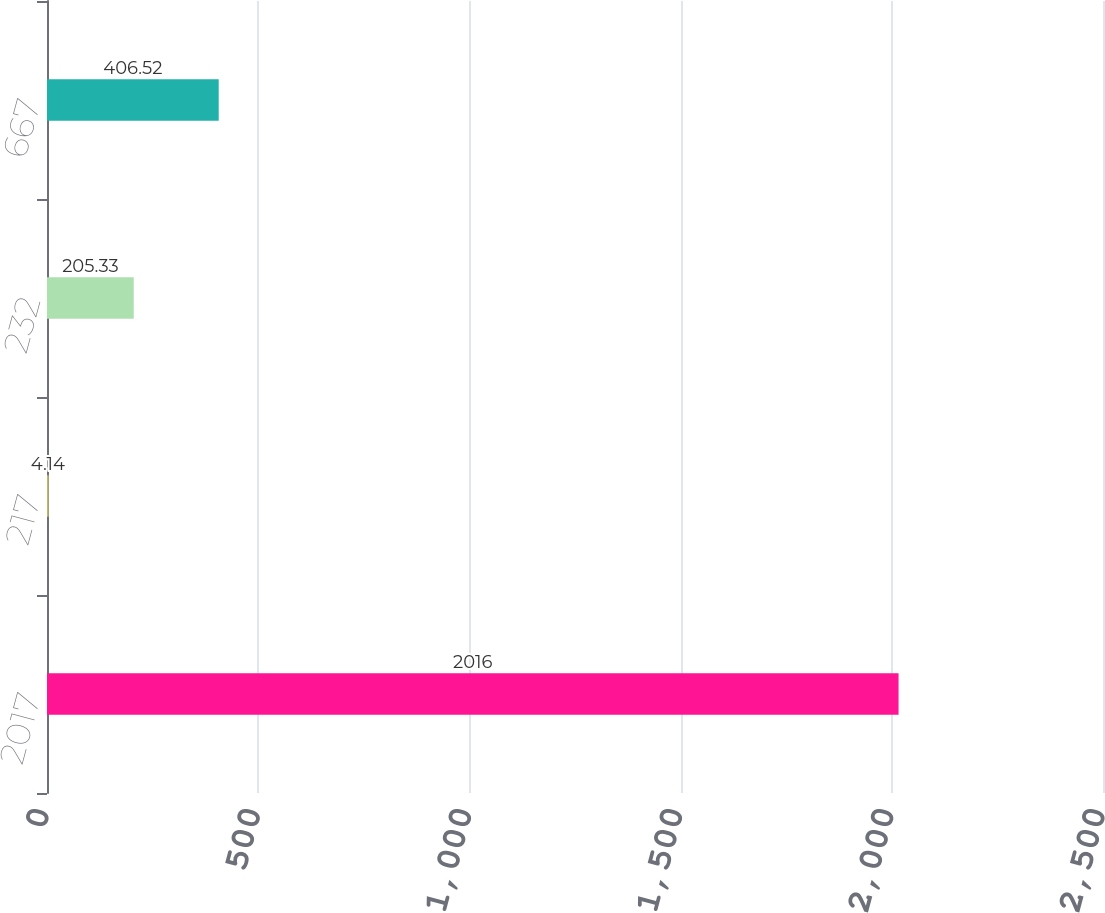<chart> <loc_0><loc_0><loc_500><loc_500><bar_chart><fcel>2017<fcel>217<fcel>232<fcel>667<nl><fcel>2016<fcel>4.14<fcel>205.33<fcel>406.52<nl></chart> 